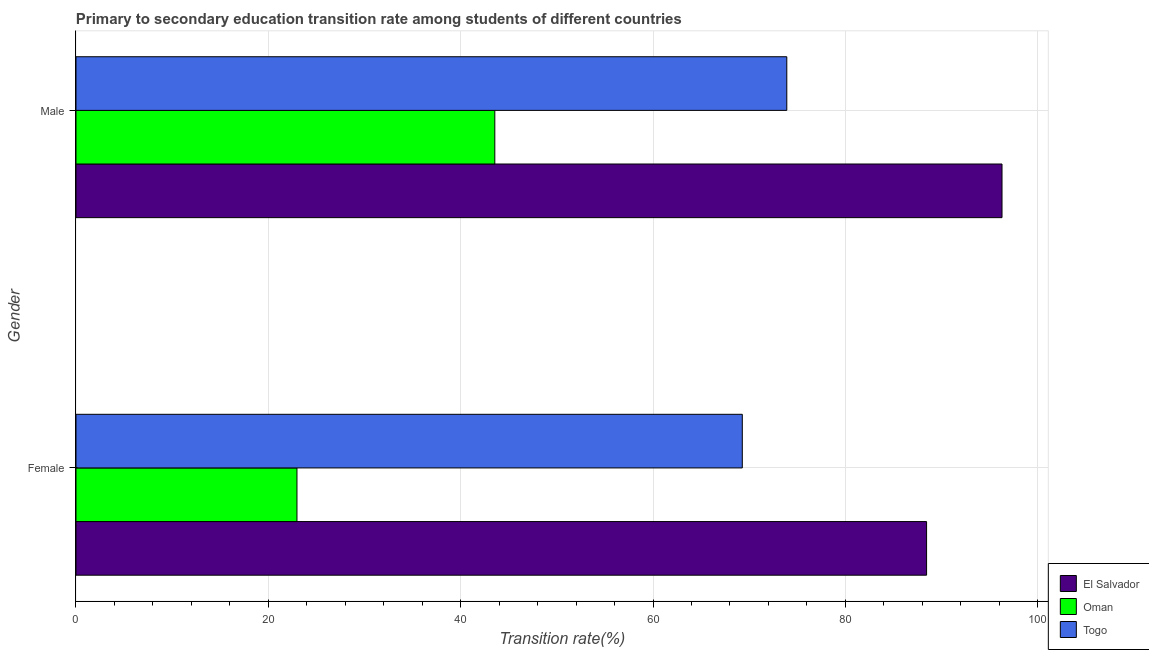Are the number of bars per tick equal to the number of legend labels?
Make the answer very short. Yes. Are the number of bars on each tick of the Y-axis equal?
Provide a succinct answer. Yes. How many bars are there on the 1st tick from the bottom?
Keep it short and to the point. 3. What is the label of the 1st group of bars from the top?
Ensure brevity in your answer.  Male. What is the transition rate among female students in Oman?
Your answer should be very brief. 22.98. Across all countries, what is the maximum transition rate among female students?
Offer a terse response. 88.45. Across all countries, what is the minimum transition rate among male students?
Your response must be concise. 43.55. In which country was the transition rate among male students maximum?
Keep it short and to the point. El Salvador. In which country was the transition rate among female students minimum?
Offer a terse response. Oman. What is the total transition rate among male students in the graph?
Provide a short and direct response. 213.75. What is the difference between the transition rate among male students in Oman and that in Togo?
Your answer should be very brief. -30.36. What is the difference between the transition rate among male students in Togo and the transition rate among female students in Oman?
Keep it short and to the point. 50.94. What is the average transition rate among male students per country?
Provide a short and direct response. 71.25. What is the difference between the transition rate among male students and transition rate among female students in Oman?
Offer a very short reply. 20.57. In how many countries, is the transition rate among female students greater than 24 %?
Give a very brief answer. 2. What is the ratio of the transition rate among female students in Togo to that in Oman?
Provide a succinct answer. 3.02. What does the 2nd bar from the top in Male represents?
Offer a terse response. Oman. What does the 2nd bar from the bottom in Female represents?
Your response must be concise. Oman. What is the difference between two consecutive major ticks on the X-axis?
Make the answer very short. 20. Are the values on the major ticks of X-axis written in scientific E-notation?
Keep it short and to the point. No. Does the graph contain any zero values?
Your answer should be compact. No. Where does the legend appear in the graph?
Give a very brief answer. Bottom right. How many legend labels are there?
Offer a terse response. 3. How are the legend labels stacked?
Your answer should be very brief. Vertical. What is the title of the graph?
Ensure brevity in your answer.  Primary to secondary education transition rate among students of different countries. What is the label or title of the X-axis?
Give a very brief answer. Transition rate(%). What is the label or title of the Y-axis?
Your response must be concise. Gender. What is the Transition rate(%) in El Salvador in Female?
Offer a terse response. 88.45. What is the Transition rate(%) of Oman in Female?
Ensure brevity in your answer.  22.98. What is the Transition rate(%) in Togo in Female?
Provide a short and direct response. 69.29. What is the Transition rate(%) of El Salvador in Male?
Your answer should be compact. 96.29. What is the Transition rate(%) in Oman in Male?
Give a very brief answer. 43.55. What is the Transition rate(%) in Togo in Male?
Keep it short and to the point. 73.91. Across all Gender, what is the maximum Transition rate(%) in El Salvador?
Your answer should be very brief. 96.29. Across all Gender, what is the maximum Transition rate(%) of Oman?
Keep it short and to the point. 43.55. Across all Gender, what is the maximum Transition rate(%) of Togo?
Your response must be concise. 73.91. Across all Gender, what is the minimum Transition rate(%) of El Salvador?
Provide a short and direct response. 88.45. Across all Gender, what is the minimum Transition rate(%) of Oman?
Give a very brief answer. 22.98. Across all Gender, what is the minimum Transition rate(%) of Togo?
Make the answer very short. 69.29. What is the total Transition rate(%) in El Salvador in the graph?
Keep it short and to the point. 184.74. What is the total Transition rate(%) of Oman in the graph?
Your response must be concise. 66.53. What is the total Transition rate(%) in Togo in the graph?
Give a very brief answer. 143.2. What is the difference between the Transition rate(%) in El Salvador in Female and that in Male?
Your response must be concise. -7.84. What is the difference between the Transition rate(%) of Oman in Female and that in Male?
Give a very brief answer. -20.57. What is the difference between the Transition rate(%) in Togo in Female and that in Male?
Provide a succinct answer. -4.63. What is the difference between the Transition rate(%) of El Salvador in Female and the Transition rate(%) of Oman in Male?
Give a very brief answer. 44.9. What is the difference between the Transition rate(%) in El Salvador in Female and the Transition rate(%) in Togo in Male?
Your answer should be very brief. 14.53. What is the difference between the Transition rate(%) in Oman in Female and the Transition rate(%) in Togo in Male?
Provide a short and direct response. -50.94. What is the average Transition rate(%) of El Salvador per Gender?
Make the answer very short. 92.37. What is the average Transition rate(%) in Oman per Gender?
Offer a very short reply. 33.26. What is the average Transition rate(%) in Togo per Gender?
Give a very brief answer. 71.6. What is the difference between the Transition rate(%) of El Salvador and Transition rate(%) of Oman in Female?
Make the answer very short. 65.47. What is the difference between the Transition rate(%) in El Salvador and Transition rate(%) in Togo in Female?
Your answer should be compact. 19.16. What is the difference between the Transition rate(%) of Oman and Transition rate(%) of Togo in Female?
Offer a terse response. -46.31. What is the difference between the Transition rate(%) in El Salvador and Transition rate(%) in Oman in Male?
Make the answer very short. 52.74. What is the difference between the Transition rate(%) in El Salvador and Transition rate(%) in Togo in Male?
Provide a short and direct response. 22.38. What is the difference between the Transition rate(%) in Oman and Transition rate(%) in Togo in Male?
Offer a very short reply. -30.36. What is the ratio of the Transition rate(%) in El Salvador in Female to that in Male?
Provide a succinct answer. 0.92. What is the ratio of the Transition rate(%) in Oman in Female to that in Male?
Keep it short and to the point. 0.53. What is the ratio of the Transition rate(%) of Togo in Female to that in Male?
Your answer should be compact. 0.94. What is the difference between the highest and the second highest Transition rate(%) of El Salvador?
Offer a very short reply. 7.84. What is the difference between the highest and the second highest Transition rate(%) in Oman?
Make the answer very short. 20.57. What is the difference between the highest and the second highest Transition rate(%) of Togo?
Make the answer very short. 4.63. What is the difference between the highest and the lowest Transition rate(%) of El Salvador?
Give a very brief answer. 7.84. What is the difference between the highest and the lowest Transition rate(%) in Oman?
Keep it short and to the point. 20.57. What is the difference between the highest and the lowest Transition rate(%) in Togo?
Offer a very short reply. 4.63. 